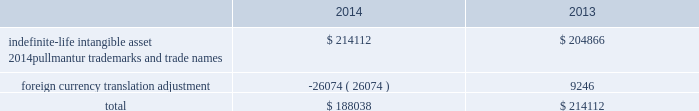Royal caribbean cruises ltd .
79 notes to the consolidated financial statements in 2012 , we determined the implied fair value of good- will for the pullmantur reporting unit was $ 145.5 mil- lion and recognized an impairment charge of $ 319.2 million based on a probability-weighted discounted cash flow model further discussed below .
This impair- ment charge was recognized in earnings during the fourth quarter of 2012 and is reported within impair- ment of pullmantur related assets within our consoli- dated statements of comprehensive income ( loss ) .
During the fourth quarter of 2014 , we performed a qualitative assessment of whether it was more-likely- than-not that our royal caribbean international reporting unit 2019s fair value was less than its carrying amount before applying the two-step goodwill impair- ment test .
The qualitative analysis included assessing the impact of certain factors such as general economic conditions , limitations on accessing capital , changes in forecasted operating results , changes in fuel prices and fluctuations in foreign exchange rates .
Based on our qualitative assessment , we concluded that it was more-likely-than-not that the estimated fair value of the royal caribbean international reporting unit exceeded its carrying value and thus , we did not pro- ceed to the two-step goodwill impairment test .
No indicators of impairment exist primarily because the reporting unit 2019s fair value has consistently exceeded its carrying value by a significant margin , its financial performance has been solid in the face of mixed economic environments and forecasts of operating results generated by the reporting unit appear suffi- cient to support its carrying value .
We also performed our annual impairment review of goodwill for pullmantur 2019s reporting unit during the fourth quarter of 2014 .
We did not perform a quali- tative assessment but instead proceeded directly to the two-step goodwill impairment test .
We estimated the fair value of the pullmantur reporting unit using a probability-weighted discounted cash flow model .
The principal assumptions used in the discounted cash flow model are projected operating results , weighted- average cost of capital , and terminal value .
Signifi- cantly impacting these assumptions are the transfer of vessels from our other cruise brands to pullmantur .
The discounted cash flow model used our 2015 pro- jected operating results as a base .
To that base , we added future years 2019 cash flows assuming multiple rev- enue and expense scenarios that reflect the impact of different global economic environments beyond 2015 on pullmantur 2019s reporting unit .
We assigned a probability to each revenue and expense scenario .
We discounted the projected cash flows using rates specific to pullmantur 2019s reporting unit based on its weighted-average cost of capital .
Based on the probability-weighted discounted cash flows , we deter- mined the fair value of the pullmantur reporting unit exceeded its carrying value by approximately 52% ( 52 % ) resulting in no impairment to pullmantur 2019s goodwill .
Pullmantur is a brand targeted primarily at the spanish , portuguese and latin american markets , with an increasing focus on latin america .
The persistent economic instability in these markets has created sig- nificant uncertainties in forecasting operating results and future cash flows used in our impairment analyses .
We continue to monitor economic events in these markets for their potential impact on pullmantur 2019s business and valuation .
Further , the estimation of fair value utilizing discounted expected future cash flows includes numerous uncertainties which require our significant judgment when making assumptions of expected revenues , operating costs , marketing , sell- ing and administrative expenses , interest rates , ship additions and retirements as well as assumptions regarding the cruise vacation industry 2019s competitive environment and general economic and business conditions , among other factors .
If there are changes to the projected future cash flows used in the impairment analyses , especially in net yields or if certain transfers of vessels from our other cruise brands to the pullmantur fleet do not take place , it is possible that an impairment charge of pullmantur 2019s reporting unit 2019s goodwill may be required .
Of these factors , the planned transfers of vessels to the pullmantur fleet is most significant to the projected future cash flows .
If the transfers do not occur , we will likely fail step one of the impairment test .
Note 4 .
Intangible assets intangible assets are reported in other assets in our consolidated balance sheets and consist of the follow- ing ( in thousands ) : .
During the fourth quarter of 2014 , 2013 and 2012 , we performed the annual impairment review of pullmantur 2019s trademarks and trade names using a discounted cash flow model and the relief-from-royalty method to compare the fair value of these indefinite-lived intan- gible assets to its carrying value .
The royalty rate used is based on comparable royalty agreements in the tourism and hospitality industry .
We used a dis- count rate comparable to the rate used in valuing the pullmantur reporting unit in our goodwill impairment test .
Based on the results of our testing , we did not .
From 2013-2014 , what percentage of total intangible assets were recorded in 2014? 
Computations: (100 * (188038 / (188038 + 214112)))
Answer: 46.75817. 